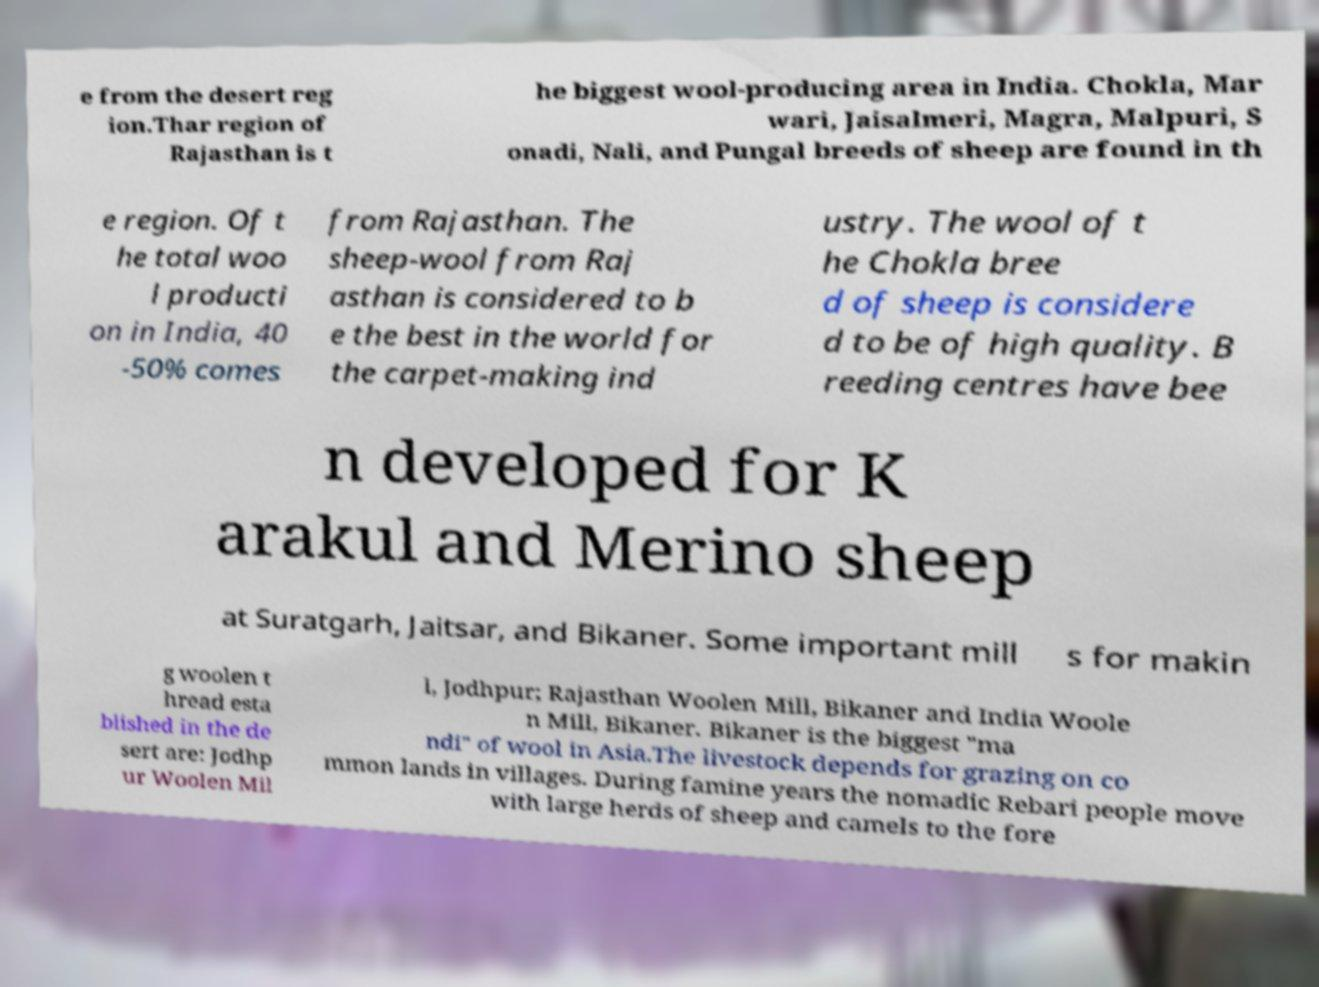Could you assist in decoding the text presented in this image and type it out clearly? e from the desert reg ion.Thar region of Rajasthan is t he biggest wool-producing area in India. Chokla, Mar wari, Jaisalmeri, Magra, Malpuri, S onadi, Nali, and Pungal breeds of sheep are found in th e region. Of t he total woo l producti on in India, 40 -50% comes from Rajasthan. The sheep-wool from Raj asthan is considered to b e the best in the world for the carpet-making ind ustry. The wool of t he Chokla bree d of sheep is considere d to be of high quality. B reeding centres have bee n developed for K arakul and Merino sheep at Suratgarh, Jaitsar, and Bikaner. Some important mill s for makin g woolen t hread esta blished in the de sert are: Jodhp ur Woolen Mil l, Jodhpur; Rajasthan Woolen Mill, Bikaner and India Woole n Mill, Bikaner. Bikaner is the biggest "ma ndi" of wool in Asia.The livestock depends for grazing on co mmon lands in villages. During famine years the nomadic Rebari people move with large herds of sheep and camels to the fore 